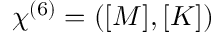Convert formula to latex. <formula><loc_0><loc_0><loc_500><loc_500>\begin{array} { r } { \chi ^ { ( 6 ) } = ( [ M ] , [ K ] ) } \end{array}</formula> 